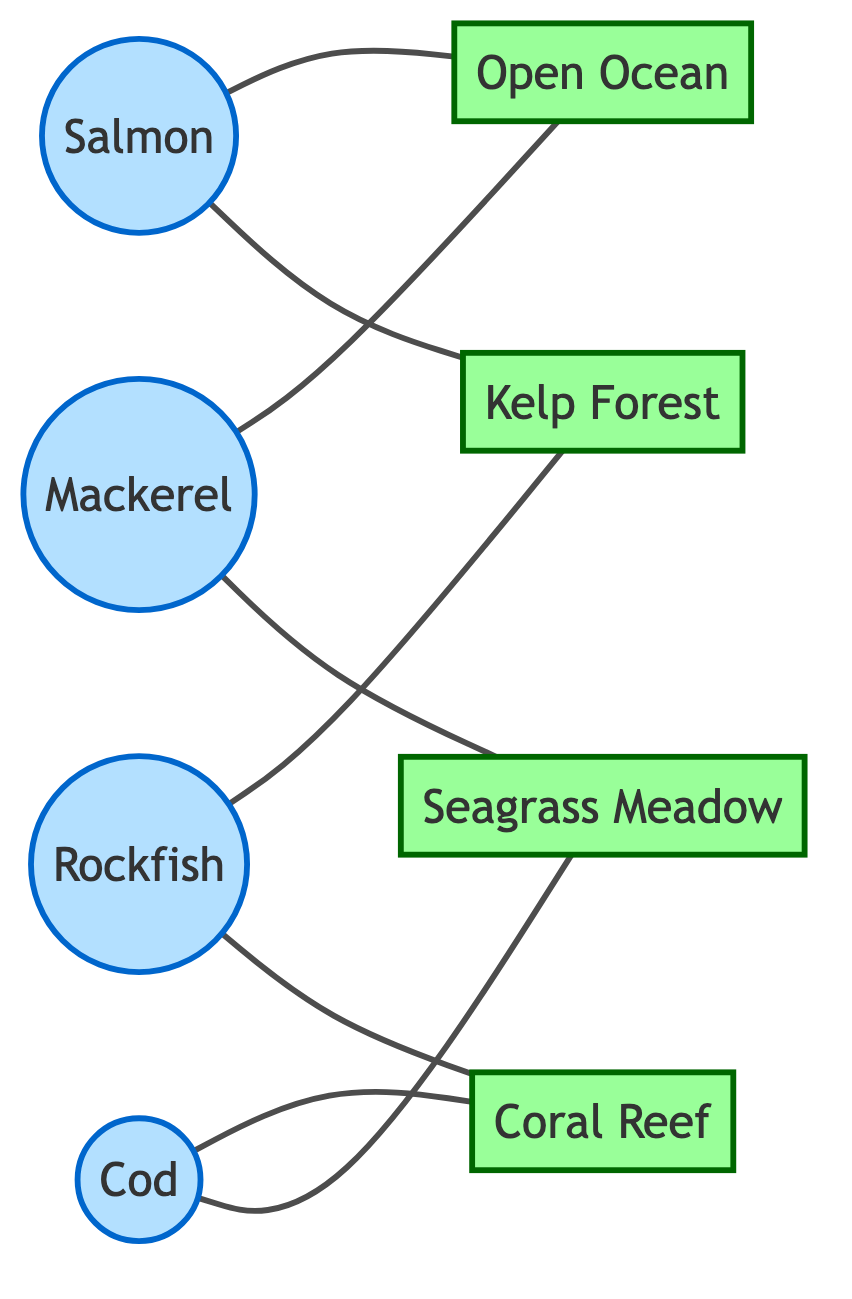What are the total number of fish species shown in the diagram? The diagram lists four fish species: Salmon, Cod, Mackerel, and Rockfish. Counting these, we find a total of four species.
Answer: 4 Which habitat is connected to Salmon? Salmon has edges connecting it to two habitats: Open Ocean and Kelp Forest. Both of these are valid answers, but since it is asking for one, we can choose the first.
Answer: Open Ocean How many habitats are represented in the diagram? The diagram shows four habitats: Kelp Forest, Coral Reef, Open Ocean, and Seagrass Meadow. Counting these reveals that there are four distinct habitats.
Answer: 4 Which fish species are associated with Coral Reef? The diagram indicates that Cod and Rockfish have edges connecting them to Coral Reef. Thus, both species are associated with this habitat.
Answer: Cod, Rockfish What is the relationship between Mackerel and Seagrass Meadow? The diagram indicates that there is an edge connecting Mackerel directly to Seagrass Meadow, meaning they are directly linked in this graph.
Answer: Directly connected How many edges are present in the diagram? By counting the edges listed in the diagram that connect fish species to their habitats, we arrive at a total of eight edges.
Answer: 8 Which fish is exclusively linked to Kelp Forest? The only fish species exclusively linked to Kelp Forest is Rockfish, as it connects to this habitat but does not connect to any other habitat in this part of the question.
Answer: Rockfish Which two species share Open Ocean as a habitat? The diagram shows that both Salmon and Mackerel are connected to the Open Ocean habitat. Therefore, these two species share this habitat.
Answer: Salmon, Mackerel Are any fish species linked to both Coral Reef and Seagrass Meadow? By inspecting the edges, we find that Cod is linked to both Coral Reef and Seagrass Meadow, making it the only fish that has connections to both habitats.
Answer: Cod 